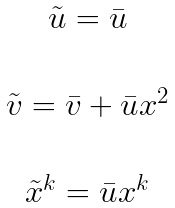<formula> <loc_0><loc_0><loc_500><loc_500>\begin{array} { c c } \tilde { u } = \bar { u } \\ \\ \tilde { v } = \bar { v } + \bar { u } x ^ { 2 } \\ \\ \tilde { x } ^ { k } = \bar { u } x ^ { k } \end{array}</formula> 